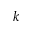Convert formula to latex. <formula><loc_0><loc_0><loc_500><loc_500>k</formula> 